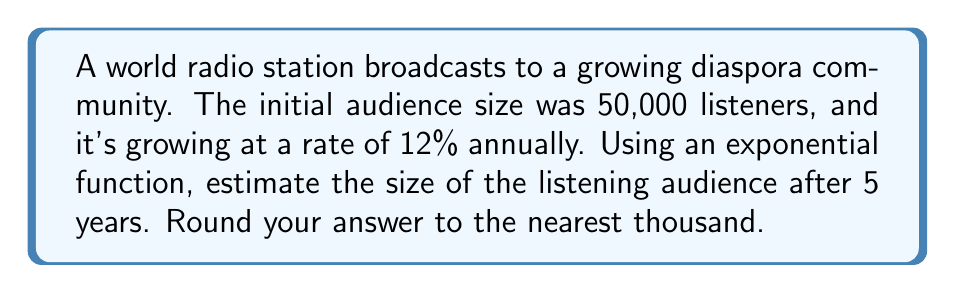Give your solution to this math problem. Let's approach this step-by-step:

1) The exponential growth function is given by:
   $$P(t) = P_0 \cdot (1 + r)^t$$
   where:
   $P(t)$ is the population at time $t$
   $P_0$ is the initial population
   $r$ is the growth rate (as a decimal)
   $t$ is the time in years

2) We know:
   $P_0 = 50,000$ (initial audience)
   $r = 0.12$ (12% annual growth rate)
   $t = 5$ years

3) Let's substitute these values into our equation:
   $$P(5) = 50,000 \cdot (1 + 0.12)^5$$

4) Simplify inside the parentheses:
   $$P(5) = 50,000 \cdot (1.12)^5$$

5) Calculate $(1.12)^5$:
   $$(1.12)^5 \approx 1.7623$$

6) Multiply:
   $$P(5) = 50,000 \cdot 1.7623 = 88,115$$

7) Rounding to the nearest thousand:
   $$P(5) \approx 88,000$$
Answer: 88,000 listeners 